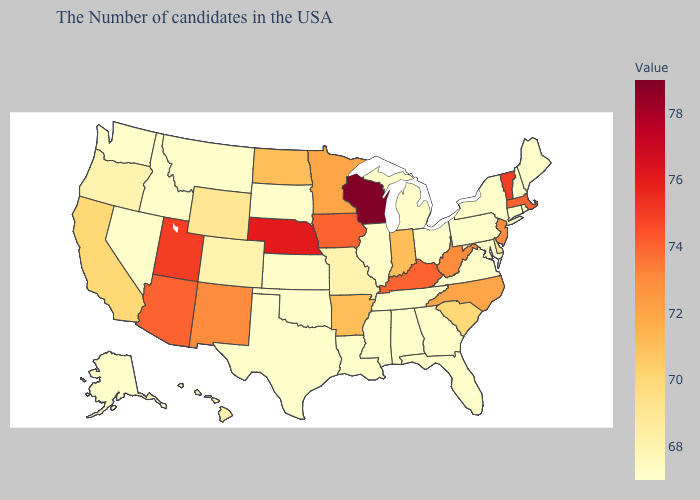Does Kentucky have the highest value in the South?
Keep it brief. Yes. Is the legend a continuous bar?
Write a very short answer. Yes. Does Wisconsin have the lowest value in the MidWest?
Concise answer only. No. Does Alabama have the lowest value in the USA?
Be succinct. Yes. 